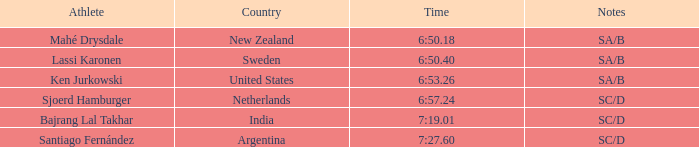What is the total of the rankings for india? 5.0. 